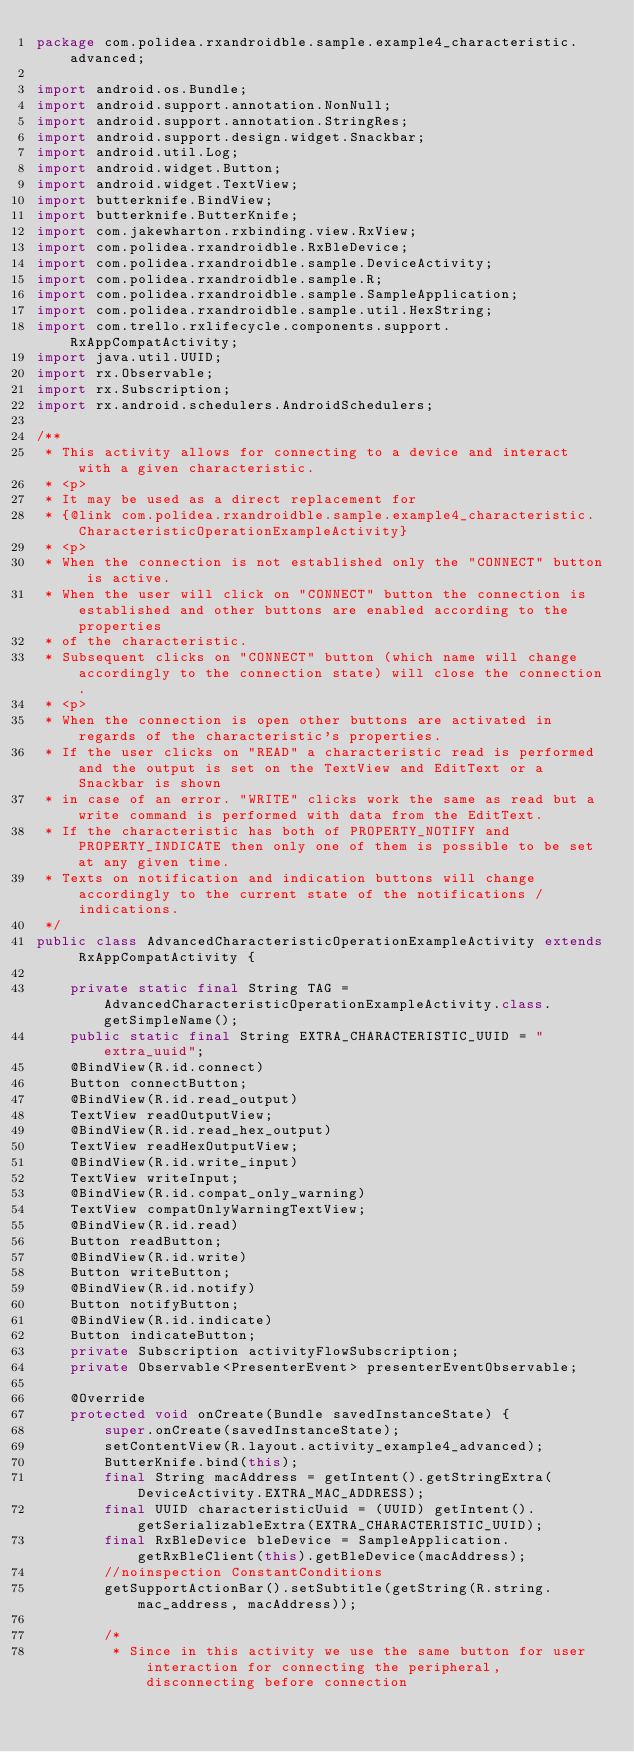Convert code to text. <code><loc_0><loc_0><loc_500><loc_500><_Java_>package com.polidea.rxandroidble.sample.example4_characteristic.advanced;

import android.os.Bundle;
import android.support.annotation.NonNull;
import android.support.annotation.StringRes;
import android.support.design.widget.Snackbar;
import android.util.Log;
import android.widget.Button;
import android.widget.TextView;
import butterknife.BindView;
import butterknife.ButterKnife;
import com.jakewharton.rxbinding.view.RxView;
import com.polidea.rxandroidble.RxBleDevice;
import com.polidea.rxandroidble.sample.DeviceActivity;
import com.polidea.rxandroidble.sample.R;
import com.polidea.rxandroidble.sample.SampleApplication;
import com.polidea.rxandroidble.sample.util.HexString;
import com.trello.rxlifecycle.components.support.RxAppCompatActivity;
import java.util.UUID;
import rx.Observable;
import rx.Subscription;
import rx.android.schedulers.AndroidSchedulers;

/**
 * This activity allows for connecting to a device and interact with a given characteristic.
 * <p>
 * It may be used as a direct replacement for
 * {@link com.polidea.rxandroidble.sample.example4_characteristic.CharacteristicOperationExampleActivity}
 * <p>
 * When the connection is not established only the "CONNECT" button is active.
 * When the user will click on "CONNECT" button the connection is established and other buttons are enabled according to the properties
 * of the characteristic.
 * Subsequent clicks on "CONNECT" button (which name will change accordingly to the connection state) will close the connection.
 * <p>
 * When the connection is open other buttons are activated in regards of the characteristic's properties.
 * If the user clicks on "READ" a characteristic read is performed and the output is set on the TextView and EditText or a Snackbar is shown
 * in case of an error. "WRITE" clicks work the same as read but a write command is performed with data from the EditText.
 * If the characteristic has both of PROPERTY_NOTIFY and PROPERTY_INDICATE then only one of them is possible to be set at any given time.
 * Texts on notification and indication buttons will change accordingly to the current state of the notifications / indications.
 */
public class AdvancedCharacteristicOperationExampleActivity extends RxAppCompatActivity {

    private static final String TAG = AdvancedCharacteristicOperationExampleActivity.class.getSimpleName();
    public static final String EXTRA_CHARACTERISTIC_UUID = "extra_uuid";
    @BindView(R.id.connect)
    Button connectButton;
    @BindView(R.id.read_output)
    TextView readOutputView;
    @BindView(R.id.read_hex_output)
    TextView readHexOutputView;
    @BindView(R.id.write_input)
    TextView writeInput;
    @BindView(R.id.compat_only_warning)
    TextView compatOnlyWarningTextView;
    @BindView(R.id.read)
    Button readButton;
    @BindView(R.id.write)
    Button writeButton;
    @BindView(R.id.notify)
    Button notifyButton;
    @BindView(R.id.indicate)
    Button indicateButton;
    private Subscription activityFlowSubscription;
    private Observable<PresenterEvent> presenterEventObservable;

    @Override
    protected void onCreate(Bundle savedInstanceState) {
        super.onCreate(savedInstanceState);
        setContentView(R.layout.activity_example4_advanced);
        ButterKnife.bind(this);
        final String macAddress = getIntent().getStringExtra(DeviceActivity.EXTRA_MAC_ADDRESS);
        final UUID characteristicUuid = (UUID) getIntent().getSerializableExtra(EXTRA_CHARACTERISTIC_UUID);
        final RxBleDevice bleDevice = SampleApplication.getRxBleClient(this).getBleDevice(macAddress);
        //noinspection ConstantConditions
        getSupportActionBar().setSubtitle(getString(R.string.mac_address, macAddress));

        /*
         * Since in this activity we use the same button for user interaction for connecting the peripheral, disconnecting before connection</code> 